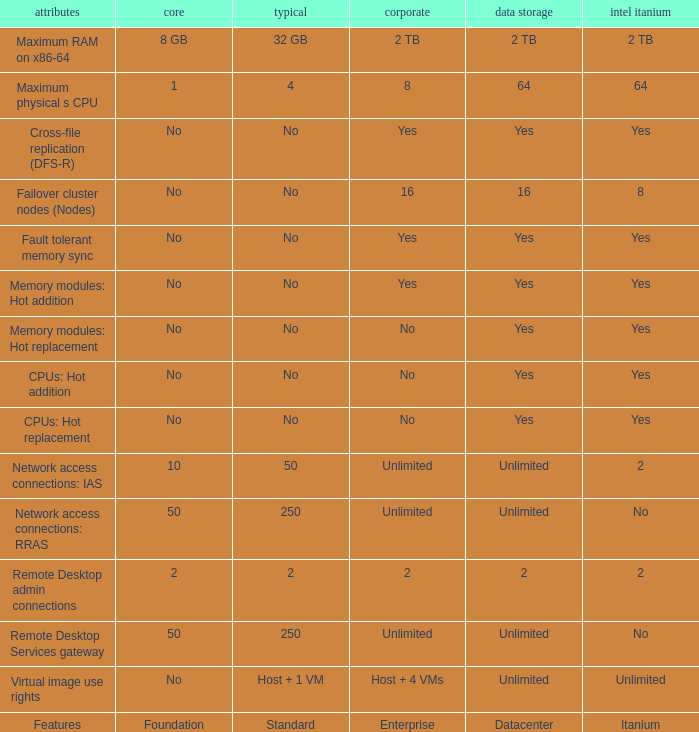What is the Datacenter for the Memory modules: hot addition Feature that has Yes listed for Itanium? Yes. Write the full table. {'header': ['attributes', 'core', 'typical', 'corporate', 'data storage', 'intel itanium'], 'rows': [['Maximum RAM on x86-64', '8 GB', '32 GB', '2 TB', '2 TB', '2 TB'], ['Maximum physical s CPU', '1', '4', '8', '64', '64'], ['Cross-file replication (DFS-R)', 'No', 'No', 'Yes', 'Yes', 'Yes'], ['Failover cluster nodes (Nodes)', 'No', 'No', '16', '16', '8'], ['Fault tolerant memory sync', 'No', 'No', 'Yes', 'Yes', 'Yes'], ['Memory modules: Hot addition', 'No', 'No', 'Yes', 'Yes', 'Yes'], ['Memory modules: Hot replacement', 'No', 'No', 'No', 'Yes', 'Yes'], ['CPUs: Hot addition', 'No', 'No', 'No', 'Yes', 'Yes'], ['CPUs: Hot replacement', 'No', 'No', 'No', 'Yes', 'Yes'], ['Network access connections: IAS', '10', '50', 'Unlimited', 'Unlimited', '2'], ['Network access connections: RRAS', '50', '250', 'Unlimited', 'Unlimited', 'No'], ['Remote Desktop admin connections', '2', '2', '2', '2', '2'], ['Remote Desktop Services gateway', '50', '250', 'Unlimited', 'Unlimited', 'No'], ['Virtual image use rights', 'No', 'Host + 1 VM', 'Host + 4 VMs', 'Unlimited', 'Unlimited'], ['Features', 'Foundation', 'Standard', 'Enterprise', 'Datacenter', 'Itanium']]} 